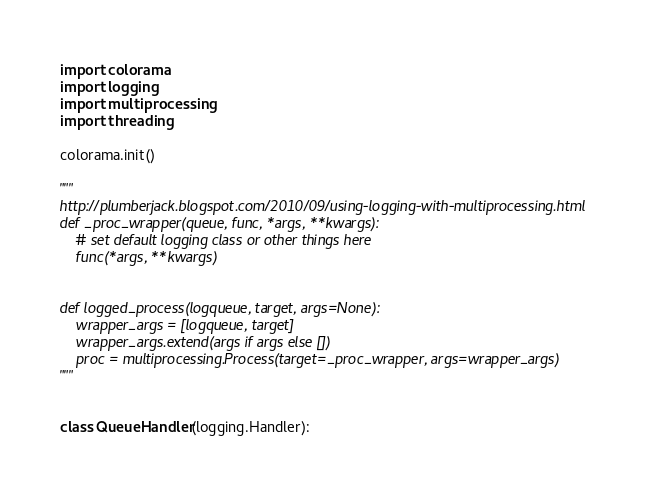Convert code to text. <code><loc_0><loc_0><loc_500><loc_500><_Python_>import colorama
import logging
import multiprocessing
import threading

colorama.init()

"""
http://plumberjack.blogspot.com/2010/09/using-logging-with-multiprocessing.html
def _proc_wrapper(queue, func, *args, **kwargs):
    # set default logging class or other things here
    func(*args, **kwargs)


def logged_process(logqueue, target, args=None):
    wrapper_args = [logqueue, target]
    wrapper_args.extend(args if args else [])
    proc = multiprocessing.Process(target=_proc_wrapper, args=wrapper_args)
"""


class QueueHandler(logging.Handler):</code> 